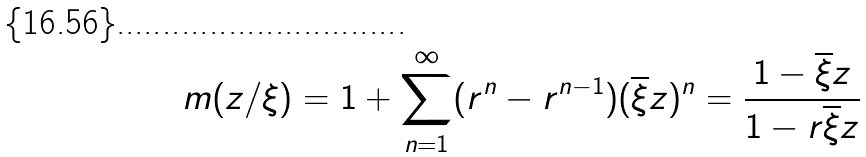Convert formula to latex. <formula><loc_0><loc_0><loc_500><loc_500>m ( z / \xi ) = 1 + \sum _ { n = 1 } ^ { \infty } ( r ^ { n } - r ^ { n - 1 } ) ( \overline { \xi } z ) ^ { n } = \frac { 1 - \overline { \xi } z } { 1 - r \overline { \xi } z }</formula> 